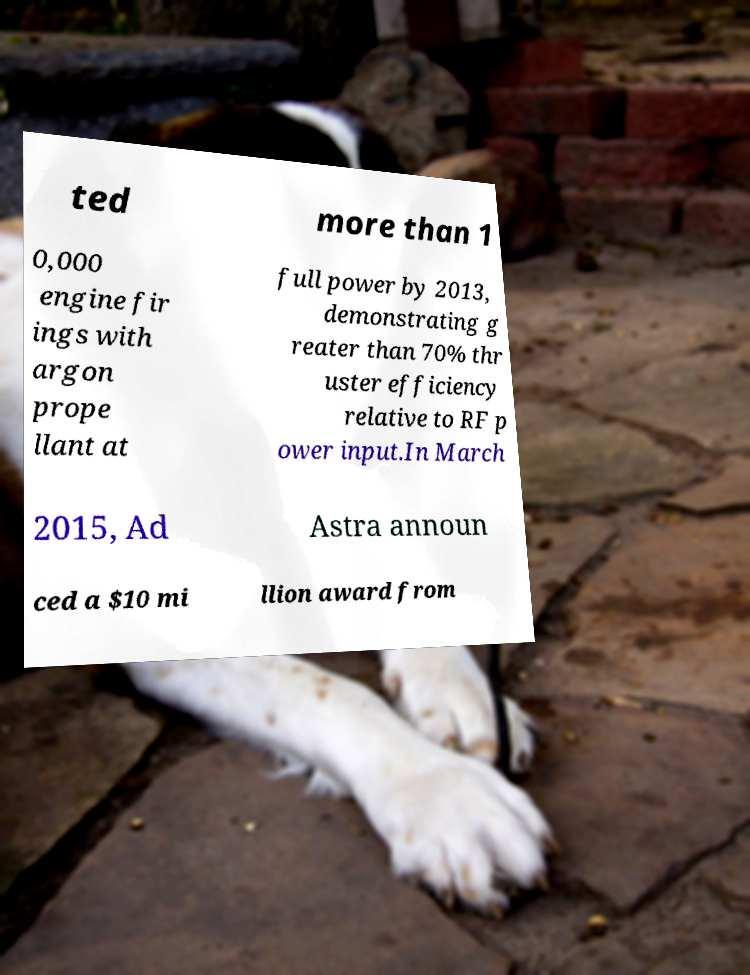Please read and relay the text visible in this image. What does it say? ted more than 1 0,000 engine fir ings with argon prope llant at full power by 2013, demonstrating g reater than 70% thr uster efficiency relative to RF p ower input.In March 2015, Ad Astra announ ced a $10 mi llion award from 